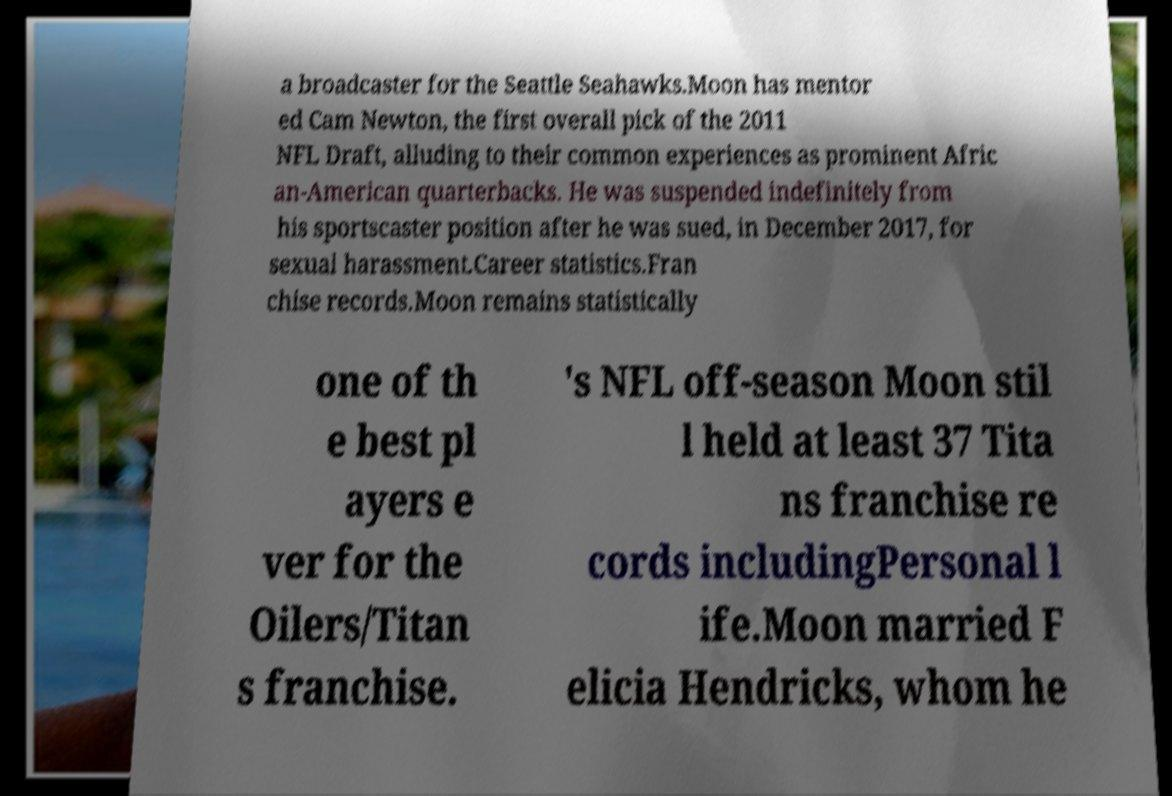Can you accurately transcribe the text from the provided image for me? a broadcaster for the Seattle Seahawks.Moon has mentor ed Cam Newton, the first overall pick of the 2011 NFL Draft, alluding to their common experiences as prominent Afric an-American quarterbacks. He was suspended indefinitely from his sportscaster position after he was sued, in December 2017, for sexual harassment.Career statistics.Fran chise records.Moon remains statistically one of th e best pl ayers e ver for the Oilers/Titan s franchise. 's NFL off-season Moon stil l held at least 37 Tita ns franchise re cords includingPersonal l ife.Moon married F elicia Hendricks, whom he 